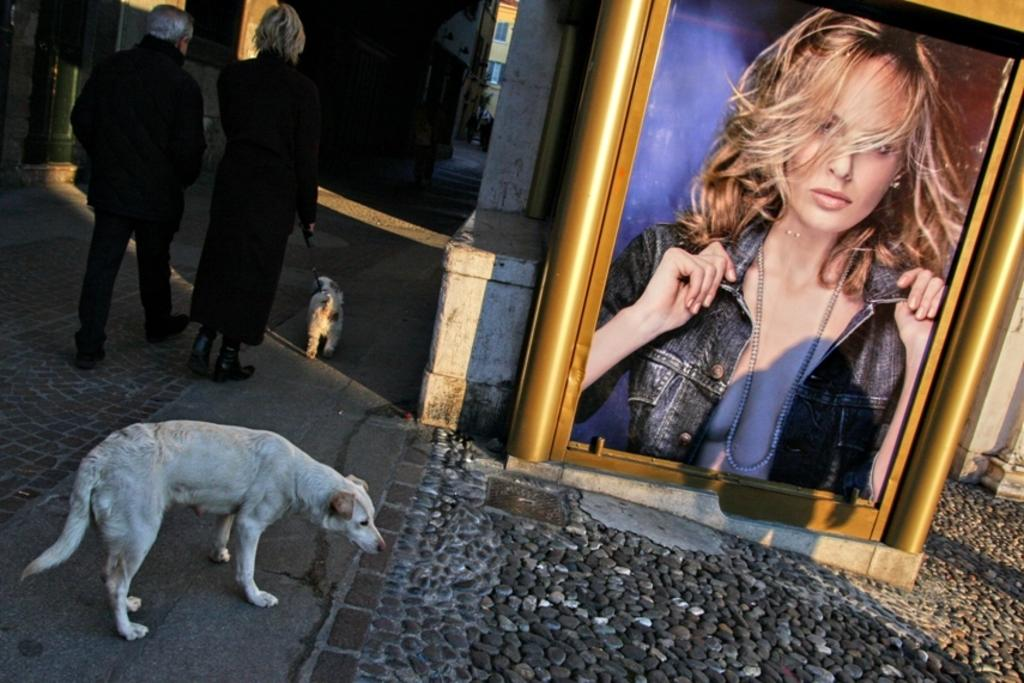What animal is on the right side of the image? There is a dog on the right side of the image. What are the two people behind the dog doing? The two people are walking behind the dog and holding it. What can be seen in the image besides the dog and the two people? There is a large photo frame in the image. What is displayed in the photo frame? There is a person's image displayed in the photo frame. What type of beam is supporting the mist in the image? There is no beam or mist present in the image. How does the expansion of the dog affect the two people walking behind it? The dog is not expanding in the image, and therefore it does not affect the two people walking behind it. 